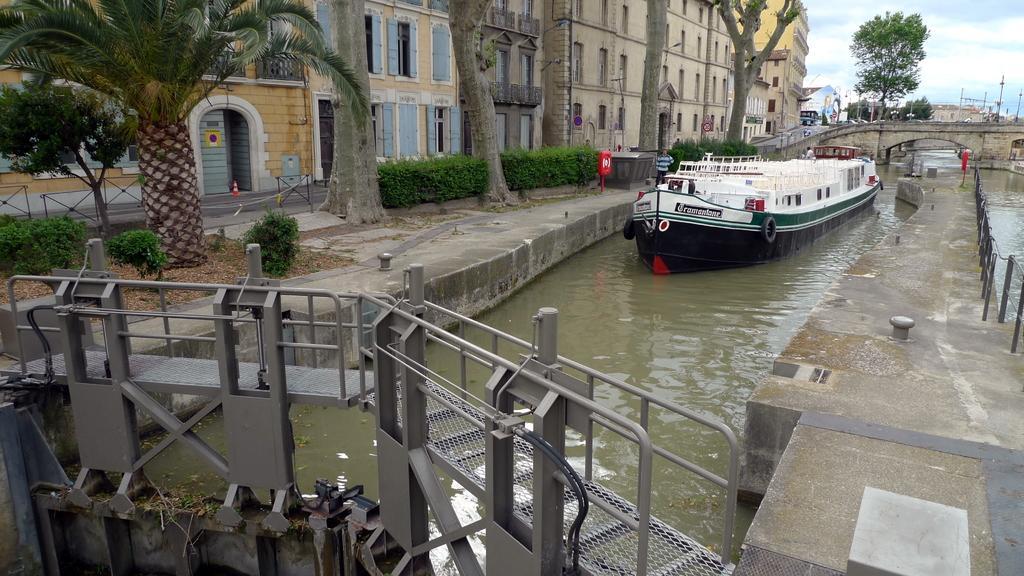Describe this image in one or two sentences. In this image in the center there is a river, and in the river there is one boat and in the foreground there is a bridge and some iron poles. On the right side and left side there is a walkway, on the right side there is a railing and on the left side there are some buildings, trees, plants, sand and some objects. In the background also there are some buildings and poles, at the top of the image there is sky. 